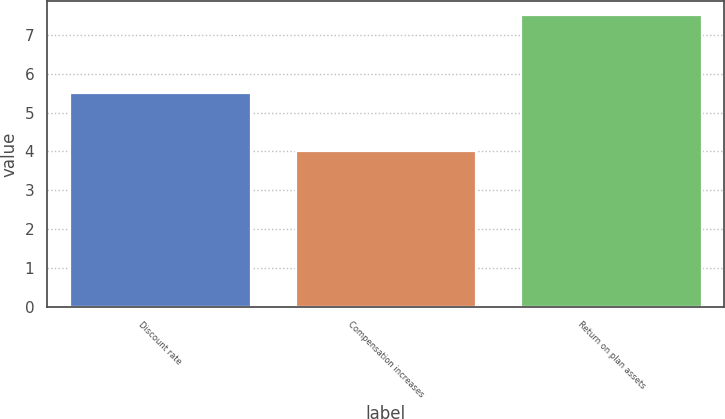Convert chart to OTSL. <chart><loc_0><loc_0><loc_500><loc_500><bar_chart><fcel>Discount rate<fcel>Compensation increases<fcel>Return on plan assets<nl><fcel>5.5<fcel>4<fcel>7.5<nl></chart> 